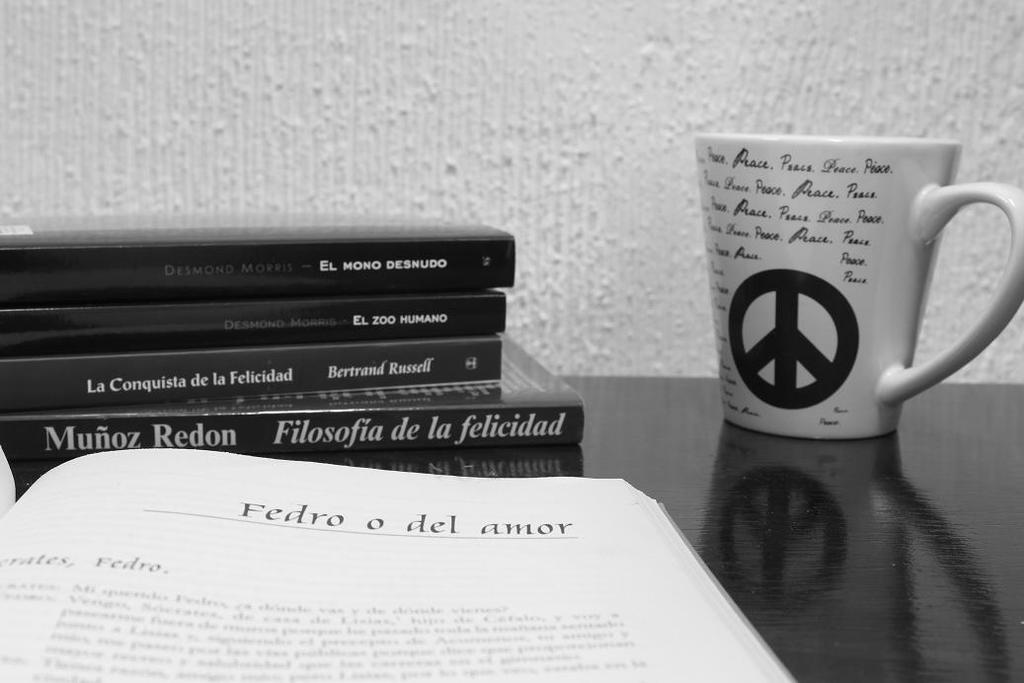<image>
Share a concise interpretation of the image provided. A stack of books with one written by Desmond Morris sitting next to a coffee mug with a peace sign and "peace" repeated in print. 